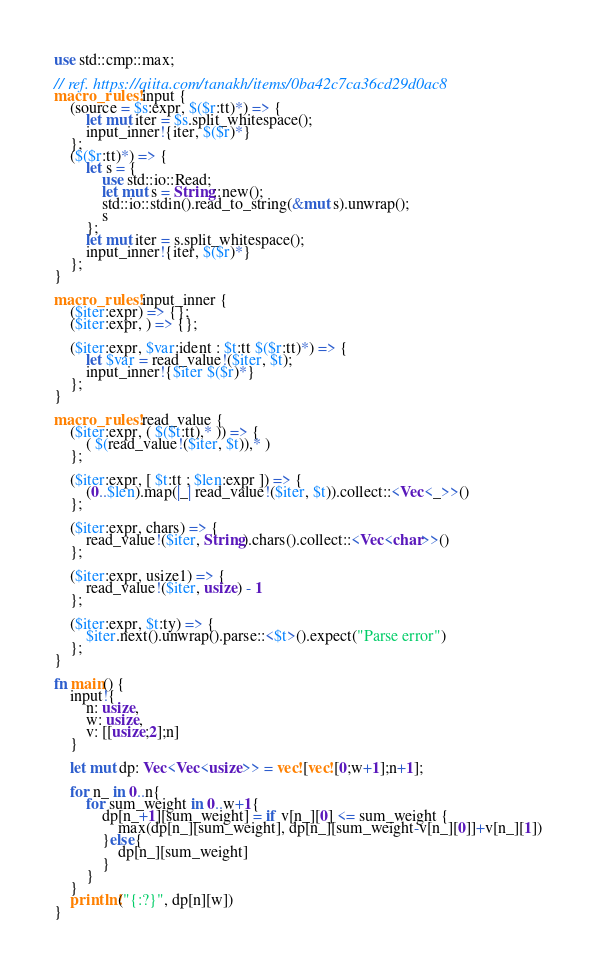Convert code to text. <code><loc_0><loc_0><loc_500><loc_500><_Rust_>use std::cmp::max;

// ref. https://qiita.com/tanakh/items/0ba42c7ca36cd29d0ac8
macro_rules! input {
    (source = $s:expr, $($r:tt)*) => {
        let mut iter = $s.split_whitespace();
        input_inner!{iter, $($r)*}
    };
    ($($r:tt)*) => {
        let s = {
            use std::io::Read;
            let mut s = String::new();
            std::io::stdin().read_to_string(&mut s).unwrap();
            s
        };
        let mut iter = s.split_whitespace();
        input_inner!{iter, $($r)*}
    };
}

macro_rules! input_inner {
    ($iter:expr) => {};
    ($iter:expr, ) => {};

    ($iter:expr, $var:ident : $t:tt $($r:tt)*) => {
        let $var = read_value!($iter, $t);
        input_inner!{$iter $($r)*}
    };
}

macro_rules! read_value {
    ($iter:expr, ( $($t:tt),* )) => {
        ( $(read_value!($iter, $t)),* )
    };

    ($iter:expr, [ $t:tt ; $len:expr ]) => {
        (0..$len).map(|_| read_value!($iter, $t)).collect::<Vec<_>>()
    };

    ($iter:expr, chars) => {
        read_value!($iter, String).chars().collect::<Vec<char>>()
    };

    ($iter:expr, usize1) => {
        read_value!($iter, usize) - 1
    };

    ($iter:expr, $t:ty) => {
        $iter.next().unwrap().parse::<$t>().expect("Parse error")
    };
}

fn main() {
    input!{
        n: usize,
        w: usize,
        v: [[usize;2];n]
    }

    let mut dp: Vec<Vec<usize>> = vec![vec![0;w+1];n+1];

    for n_ in 0..n{
        for sum_weight in 0..w+1{
            dp[n_+1][sum_weight] = if v[n_][0] <= sum_weight {
                max(dp[n_][sum_weight], dp[n_][sum_weight-v[n_][0]]+v[n_][1])
            }else{
                dp[n_][sum_weight]
            }
        }
    }
    println!("{:?}", dp[n][w])
}
</code> 